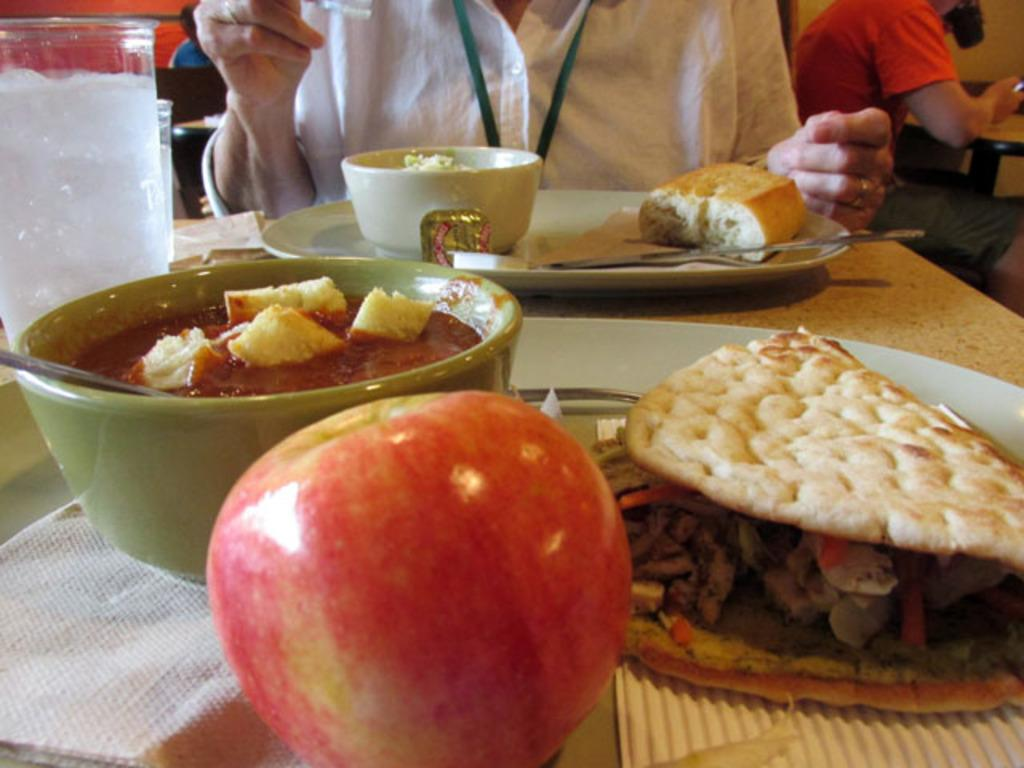What objects are present on the table in the image? There are plates, a bowl containing food items, glasses, tissues, and spoons on the table. What type of food item can be seen in the bowl? The bowl contains food items, but the specific type is not mentioned in the facts. What is the purpose of the tissues on the table? The tissues on the table might be used for wiping or cleaning purposes. What fruit is visible on the table? There is an apple on the table. Are there any people visible in the image? Yes, there are people at the top side of the image. What type of roll can be seen in the image? There is no roll present in the image. How many people are in the crowd in the image? There is no crowd present in the image; only people at the top side of the image are mentioned. 